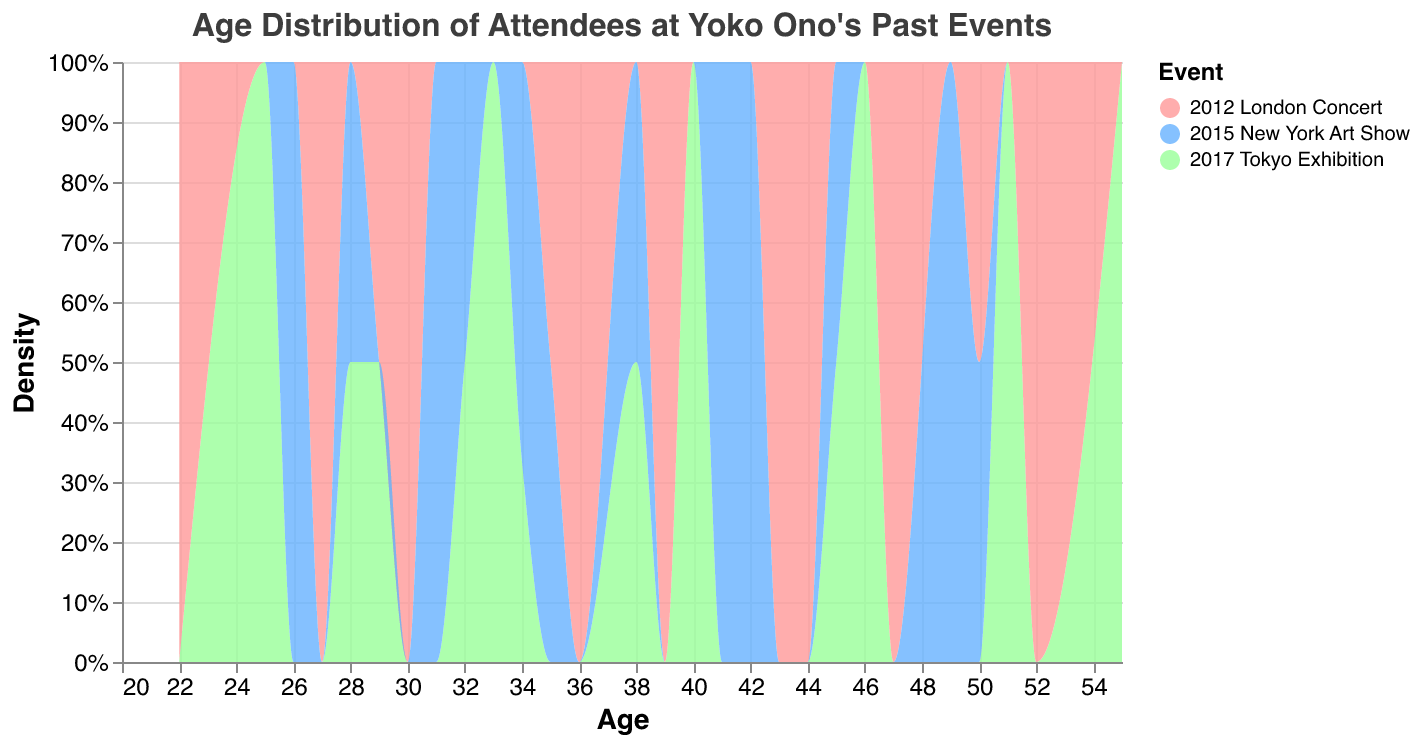What is the title of the figure? The title of the figure is usually found at the top and in this case specifies the content of the data visualization.
Answer: Age Distribution of Attendees at Yoko Ono's Past Events What are the events represented in the plot? The events can be identified by the different colors in the plot, which correspond to the legend next to the figure.
Answer: 2017 Tokyo Exhibition, 2012 London Concert, 2015 New York Art Show Which event had the highest density of attendees in their 30s? By examining the plot, we can observe the peaks and areas with higher density. The colors indicating each event will guide identifying the highest density in the specific age range.
Answer: 2012 London Concert What is the age range with the lowest density of attendees overall? By looking at the x-axis range and identifying the areas with the least shaded density for all events, we can find the age range with the lowest density.
Answer: 20-25 Which event has the highest peak density and at what age? The peak density can be identified by finding the highest point on the y-axis for any of the event-specific colored regions. Check the age value at this peak density.
Answer: 2012 London Concert at around 35 How does the density of attendees aged 40-50 compare across the events? By observing the shaded regions between the ages of 40 and 50 for each color, we can compare which event has higher or lower densities.
Answer: 2017 Tokyo Exhibition has the highest density in this range, 2012 London Concert and 2015 New York Art Show are lower What age range had the highest density of attendees for the 2015 New York Art Show? The highest density is found by identifying the peak of the 2015 New York Art Show's region and noting the corresponding age range on the x-axis.
Answer: 30-35 Which event had the most attendees aged below 30? By checking the density for ages less than 30 in the plot, the event with the larger shaded area in this age group can be identified.
Answer: 2012 London Concert What is the overall trend in attendee age distribution across all events? Comparing the general shapes of the density distributions for all events gives insight into the common age trends for attendees.
Answer: Higher attendance in the 30s and 40s, lower in 20s and 50+ 